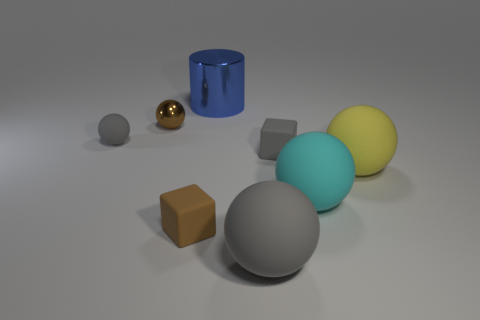Subtract all large cyan rubber balls. How many balls are left? 4 Subtract all brown blocks. How many blocks are left? 1 Subtract all cubes. How many objects are left? 6 Add 1 red metallic cylinders. How many objects exist? 9 Subtract 1 blocks. How many blocks are left? 1 Add 2 small matte blocks. How many small matte blocks exist? 4 Subtract 1 brown balls. How many objects are left? 7 Subtract all brown balls. Subtract all purple cubes. How many balls are left? 4 Subtract all red cylinders. How many cyan blocks are left? 0 Subtract all shiny spheres. Subtract all tiny brown spheres. How many objects are left? 6 